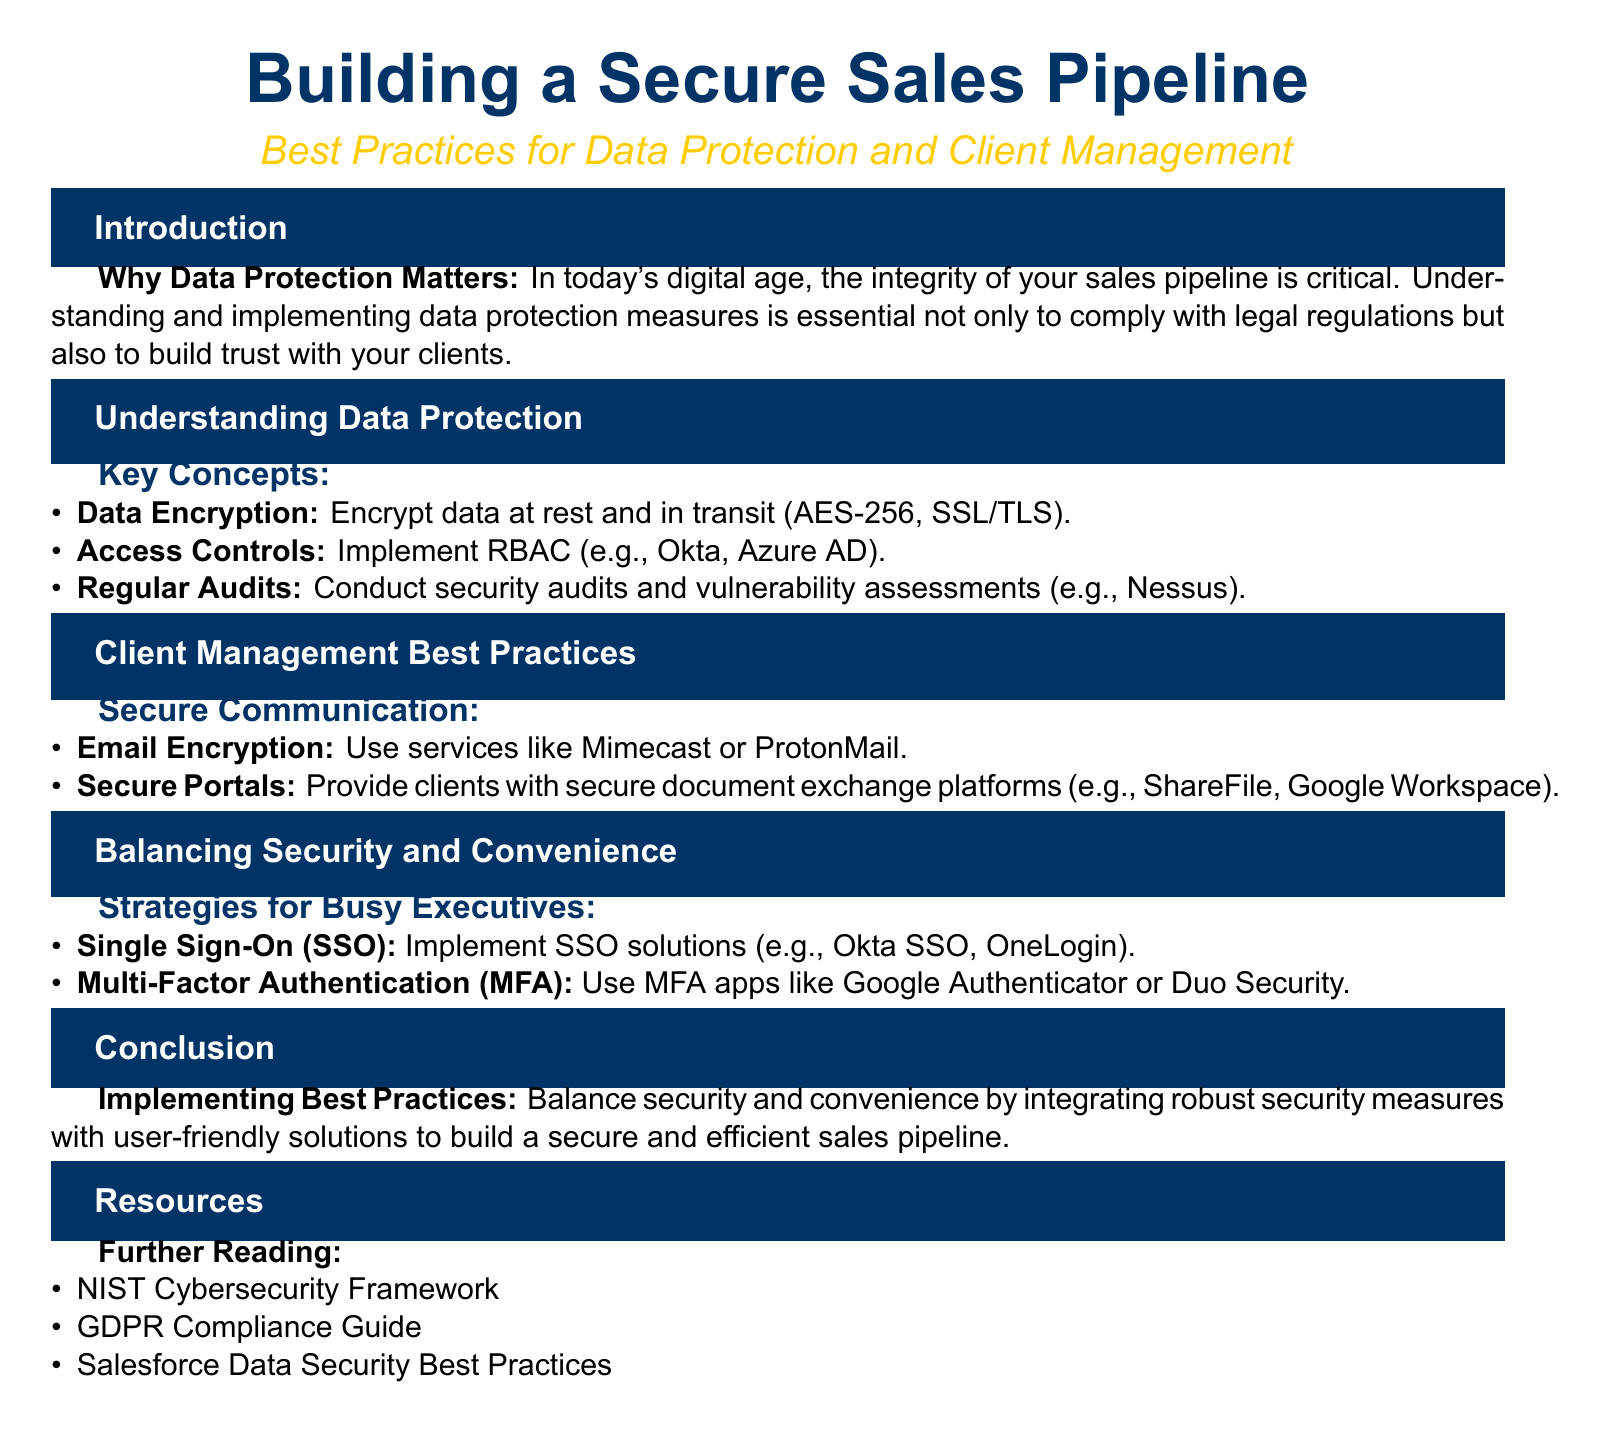what is the main title of the document? The main title highlights the focus of the document, which is centered around securing the sales pipeline.
Answer: Building a Secure Sales Pipeline what is the subtitle of the document? The subtitle provides additional context regarding the content of the document and its focus on best practices.
Answer: Best Practices for Data Protection and Client Management name one key concept related to data protection. The document lists several important concepts that are related to data protection.
Answer: Data Encryption what are two secure communication methods mentioned? The document provides examples of how to securely communicate with clients, highlighting specific services.
Answer: Email Encryption, Secure Portals what is one strategy for balancing security and convenience? This question draws from the section discussing ways to maintain security while ensuring convenience for busy executives.
Answer: Single Sign-On what does the acronym MFA stand for? The acronym is introduced as part of the security strategies to enhance protection.
Answer: Multi-Factor Authentication which organization’s cybersecurity framework is recommended for further reading? The document suggests additional resources for enhancing understanding and practices in cybersecurity.
Answer: NIST Cybersecurity Framework what is emphasized as essential for sales pipeline integrity? The document stresses a fundamental importance in maintaining client relationships and legal compliance.
Answer: Data Protection Measures how often should security audits be conducted according to the document? The document implies a routine practice for safeguarding data integrity.
Answer: Regular Audits 